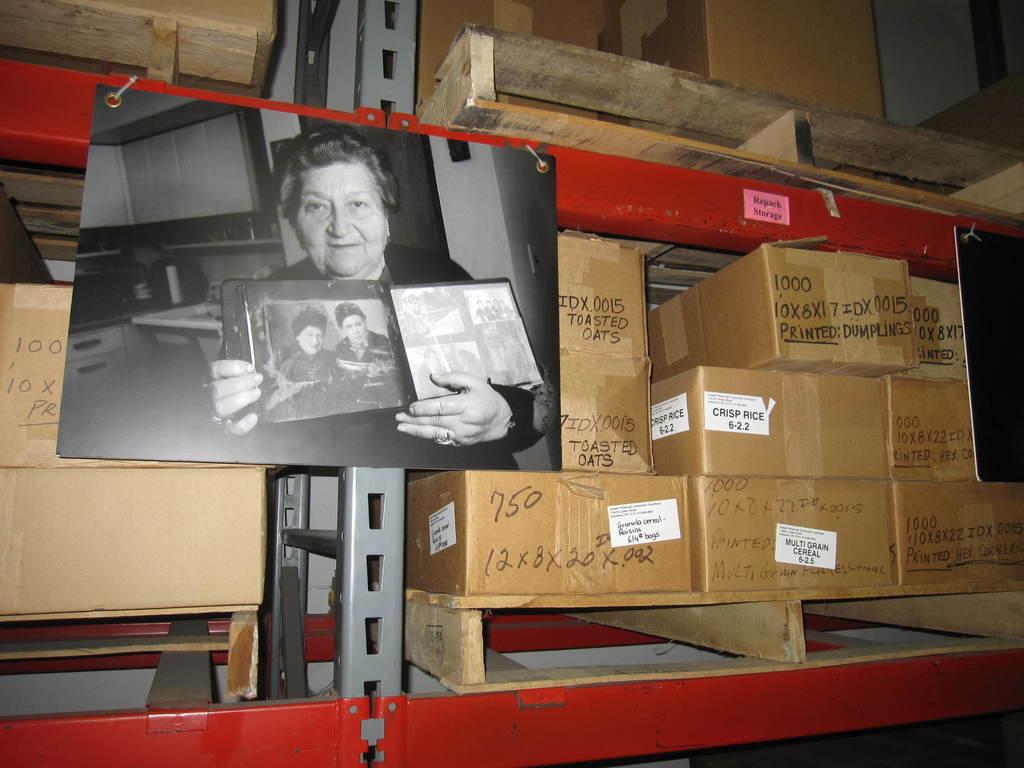What kind of oaks are in the box?
Provide a short and direct response. Toasted. 